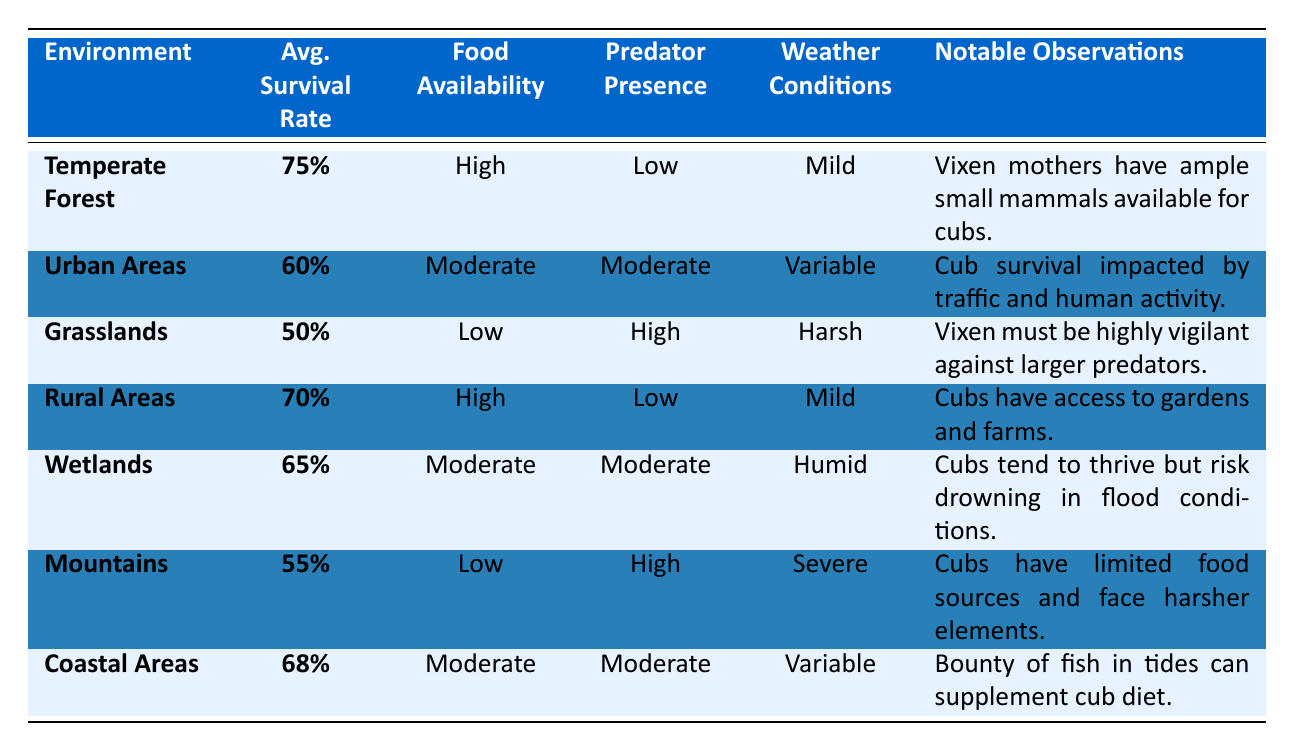What is the average survival rate in the Temperate Forest? The table shows the average survival rate for the Temperate Forest is specifically listed as 75%.
Answer: 75% Which environment has the lowest average survival rate? By comparing the average survival rates, the Grasslands have the lowest rate of 50%.
Answer: Grasslands Is the food availability classified as high in Urban Areas? The table states that food availability in Urban Areas is classified as Moderate, not High.
Answer: No What is the difference in average survival rates between Coastal Areas and Grasslands? Coastal Areas have an average survival rate of 68%, and Grasslands have 50%. The difference is 68% - 50% = 18%.
Answer: 18% In which environment do vixen cubs face the highest predator presence? The table indicates that Grasslands and Mountains both have High predator presence.
Answer: Grasslands and Mountains What environment shows a notable observation regarding the risk of drowning? The Wetlands environment notes that cubs tend to thrive but risk drowning in flood conditions.
Answer: Wetlands Calculate the average of the survival rates for Rural Areas and Wetlands. The average of Rural Areas (70%) and Wetlands (65%) is (70% + 65%) / 2 = 67.5%.
Answer: 67.5% Is average survival rate directly related to food availability based on this data? While environments with High food availability generally show higher survival rates, it is not a strict correlation, as Wetlands (Moderate food availability) have a higher rate than Grasslands (Low food availability).
Answer: No Which environment has a weather condition described as severe? The table indicates that Mountains have severe weather conditions listed.
Answer: Mountains What notable observation can be made about cubs in the Coastal Areas? The notable observation for Coastal Areas states that a bounty of fish in tides can supplement the cub diet.
Answer: Bounty of fish supplements diet 